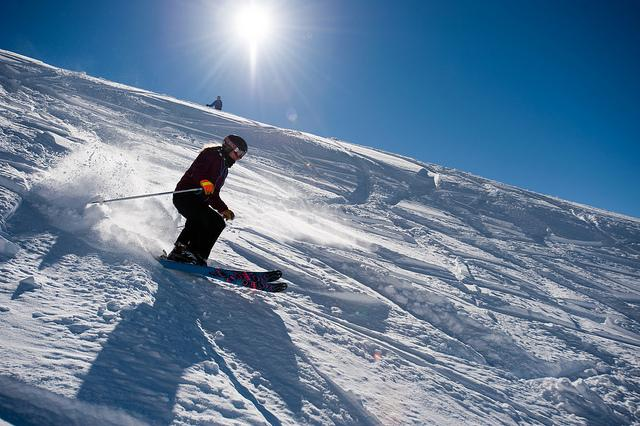Which EU country might be associated with the colors of the skier's gloves? spain 